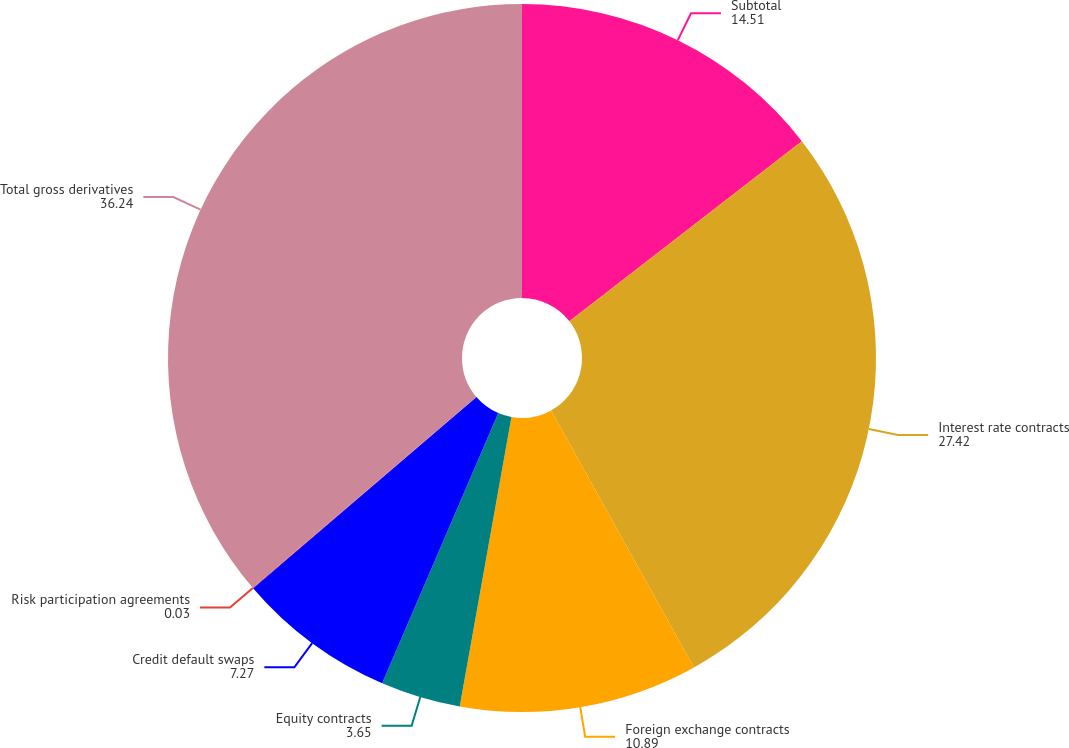<chart> <loc_0><loc_0><loc_500><loc_500><pie_chart><fcel>Subtotal<fcel>Interest rate contracts<fcel>Foreign exchange contracts<fcel>Equity contracts<fcel>Credit default swaps<fcel>Risk participation agreements<fcel>Total gross derivatives<nl><fcel>14.51%<fcel>27.42%<fcel>10.89%<fcel>3.65%<fcel>7.27%<fcel>0.03%<fcel>36.24%<nl></chart> 